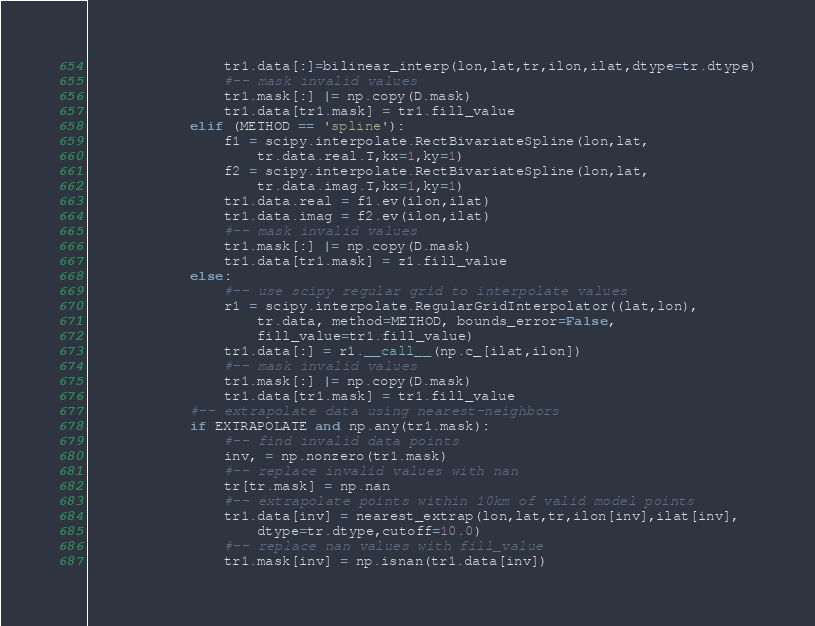Convert code to text. <code><loc_0><loc_0><loc_500><loc_500><_Python_>                tr1.data[:]=bilinear_interp(lon,lat,tr,ilon,ilat,dtype=tr.dtype)
                #-- mask invalid values
                tr1.mask[:] |= np.copy(D.mask)
                tr1.data[tr1.mask] = tr1.fill_value
            elif (METHOD == 'spline'):
                f1 = scipy.interpolate.RectBivariateSpline(lon,lat,
                    tr.data.real.T,kx=1,ky=1)
                f2 = scipy.interpolate.RectBivariateSpline(lon,lat,
                    tr.data.imag.T,kx=1,ky=1)
                tr1.data.real = f1.ev(ilon,ilat)
                tr1.data.imag = f2.ev(ilon,ilat)
                #-- mask invalid values
                tr1.mask[:] |= np.copy(D.mask)
                tr1.data[tr1.mask] = z1.fill_value
            else:
                #-- use scipy regular grid to interpolate values
                r1 = scipy.interpolate.RegularGridInterpolator((lat,lon),
                    tr.data, method=METHOD, bounds_error=False,
                    fill_value=tr1.fill_value)
                tr1.data[:] = r1.__call__(np.c_[ilat,ilon])
                #-- mask invalid values
                tr1.mask[:] |= np.copy(D.mask)
                tr1.data[tr1.mask] = tr1.fill_value
            #-- extrapolate data using nearest-neighbors
            if EXTRAPOLATE and np.any(tr1.mask):
                #-- find invalid data points
                inv, = np.nonzero(tr1.mask)
                #-- replace invalid values with nan
                tr[tr.mask] = np.nan
                #-- extrapolate points within 10km of valid model points
                tr1.data[inv] = nearest_extrap(lon,lat,tr,ilon[inv],ilat[inv],
                    dtype=tr.dtype,cutoff=10.0)
                #-- replace nan values with fill_value
                tr1.mask[inv] = np.isnan(tr1.data[inv])</code> 